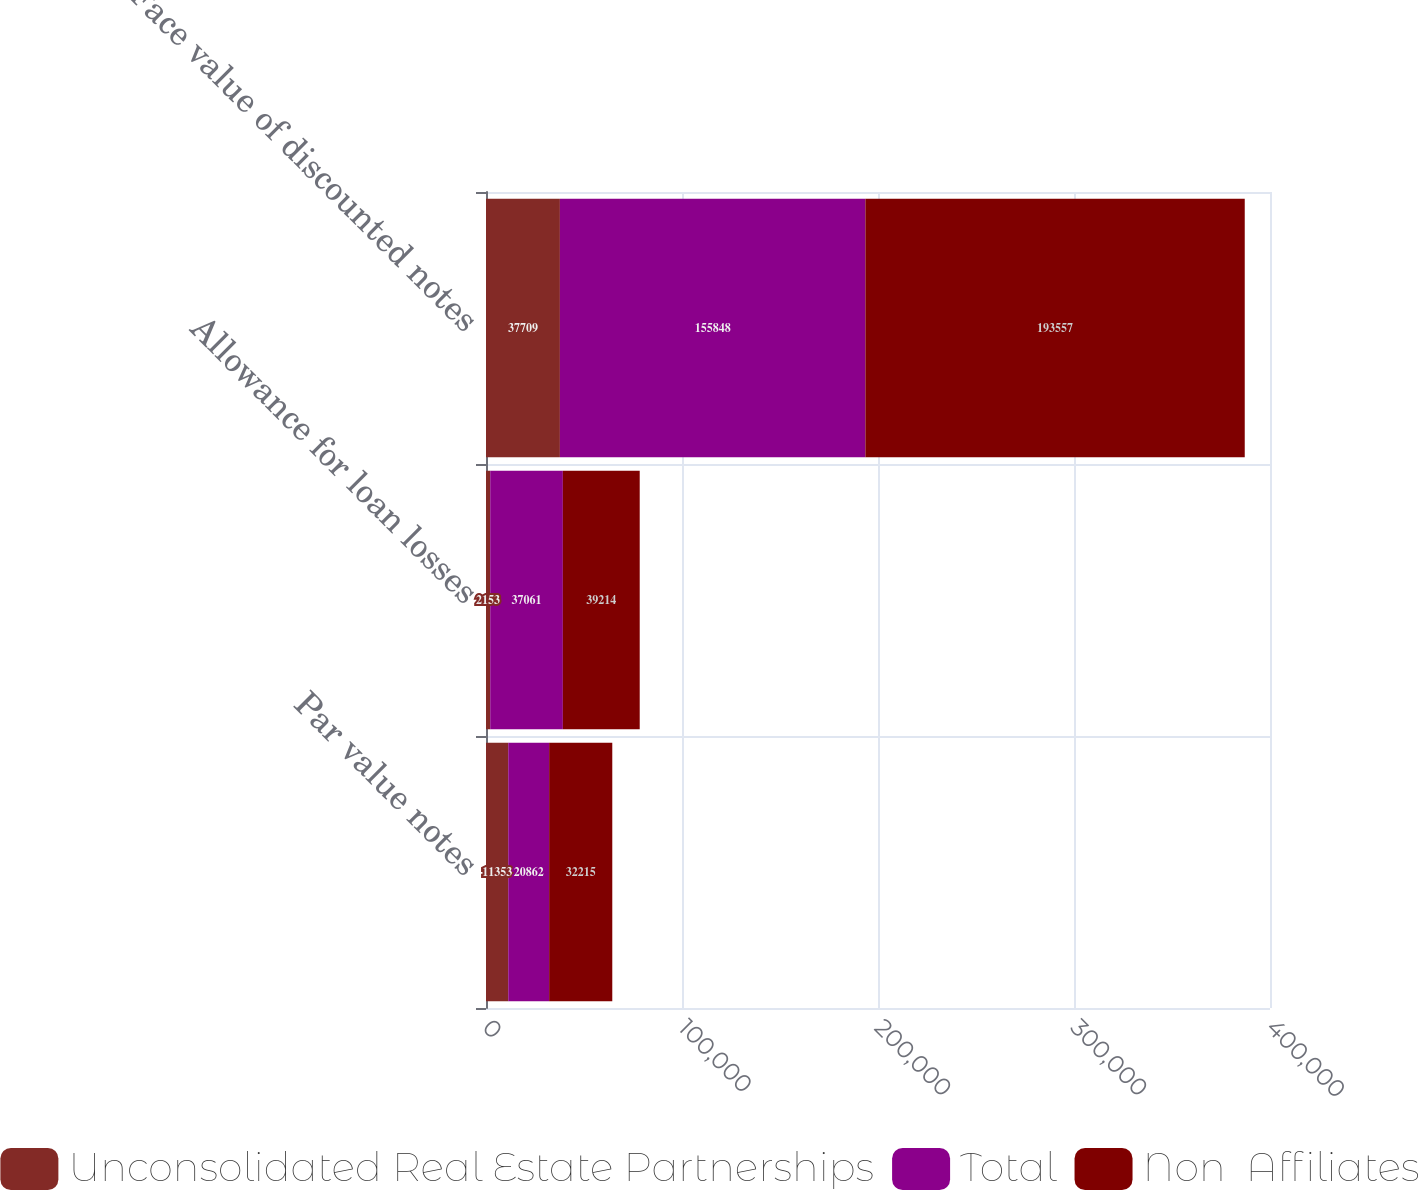Convert chart to OTSL. <chart><loc_0><loc_0><loc_500><loc_500><stacked_bar_chart><ecel><fcel>Par value notes<fcel>Allowance for loan losses<fcel>Face value of discounted notes<nl><fcel>Unconsolidated Real Estate Partnerships<fcel>11353<fcel>2153<fcel>37709<nl><fcel>Total<fcel>20862<fcel>37061<fcel>155848<nl><fcel>Non  Affiliates<fcel>32215<fcel>39214<fcel>193557<nl></chart> 